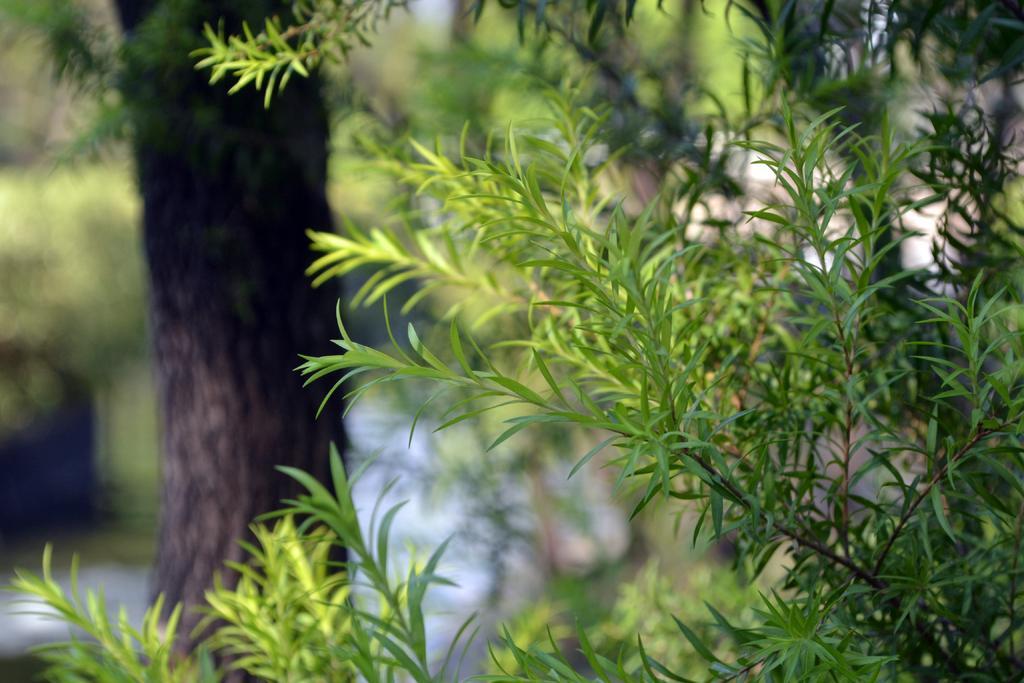Please provide a concise description of this image. In this image we can see some plants, a tree, and the background is blurred. 